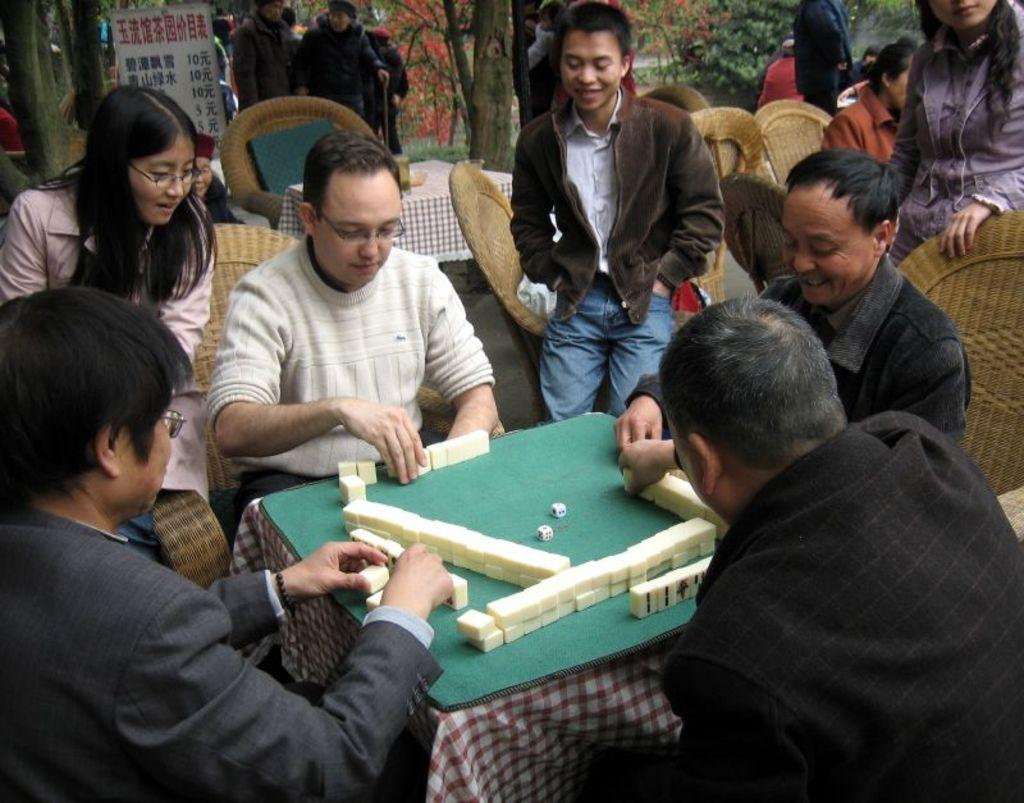What are the people in the image doing? The people in the image are sitting on chairs. Where are the chairs located in relation to the table? The chairs are in front of the table. What is on the table in the image? There is a green mat on the table. What is placed on the green mat? There is an object placed on the green mat. What hobbies do the people sitting on chairs have in common? The image does not provide information about the hobbies of the people sitting on chairs, so we cannot determine any common hobbies. 